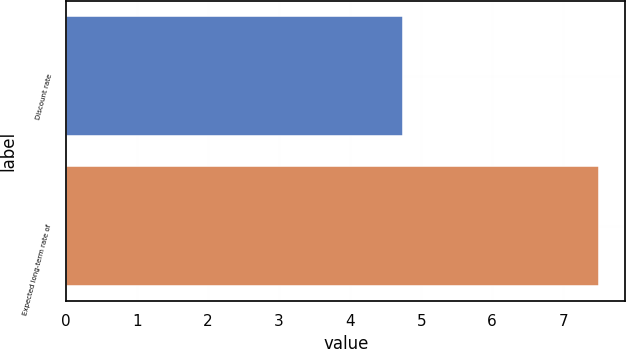<chart> <loc_0><loc_0><loc_500><loc_500><bar_chart><fcel>Discount rate<fcel>Expected long-term rate of<nl><fcel>4.75<fcel>7.5<nl></chart> 